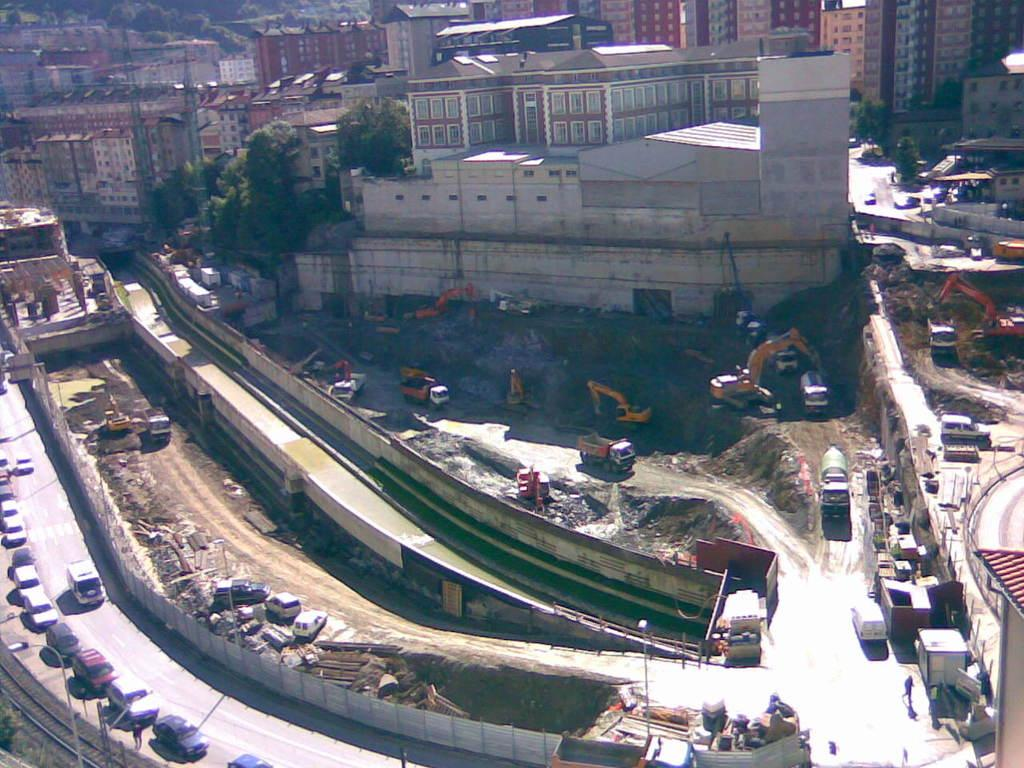What type of location is shown in the image? The image depicts a city. What can be seen on the streets of the city? There are vehicles on the road. What structures are visible in the image? There are buildings in the image. What type of vegetation is present in the city? Trees are present in the image. What can be seen illuminating the city at night? There are lights visible in the image. What objects are supporting the lights in the image? There are poles in the image. How many babies are being led by the woman in the image? There is no woman or babies present in the image; it depicts a city with vehicles, buildings, trees, lights, and poles. 